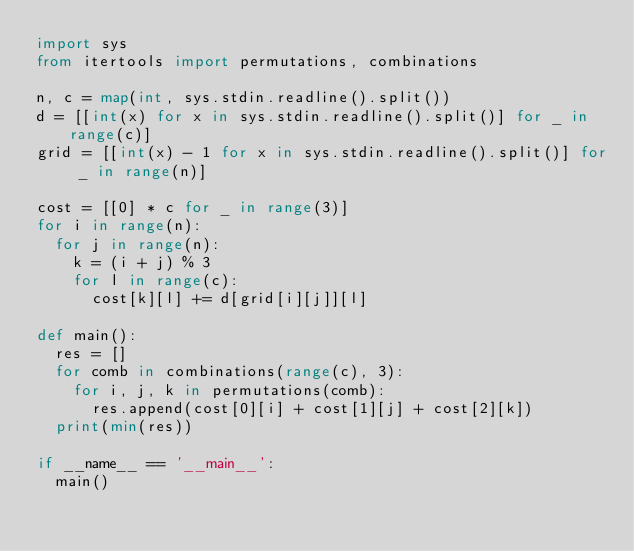<code> <loc_0><loc_0><loc_500><loc_500><_Python_>import sys
from itertools import permutations, combinations

n, c = map(int, sys.stdin.readline().split())
d = [[int(x) for x in sys.stdin.readline().split()] for _ in range(c)]
grid = [[int(x) - 1 for x in sys.stdin.readline().split()] for _ in range(n)]

cost = [[0] * c for _ in range(3)]
for i in range(n):
  for j in range(n):
    k = (i + j) % 3
    for l in range(c):
      cost[k][l] += d[grid[i][j]][l]
  
def main():
  res = []
  for comb in combinations(range(c), 3):
    for i, j, k in permutations(comb):
      res.append(cost[0][i] + cost[1][j] + cost[2][k])
  print(min(res))

if __name__ == '__main__':
  main()</code> 